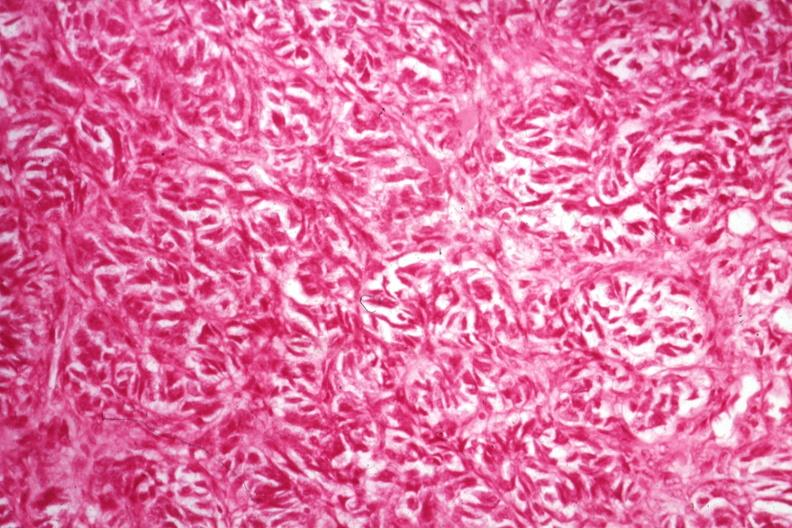s female reproductive present?
Answer the question using a single word or phrase. Yes 